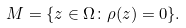<formula> <loc_0><loc_0><loc_500><loc_500>M = \{ z \in \Omega \colon \rho ( z ) = 0 \} .</formula> 